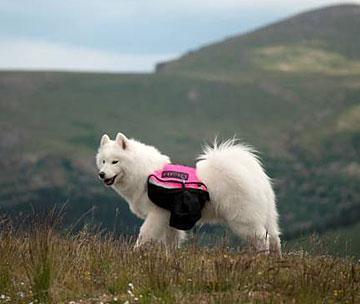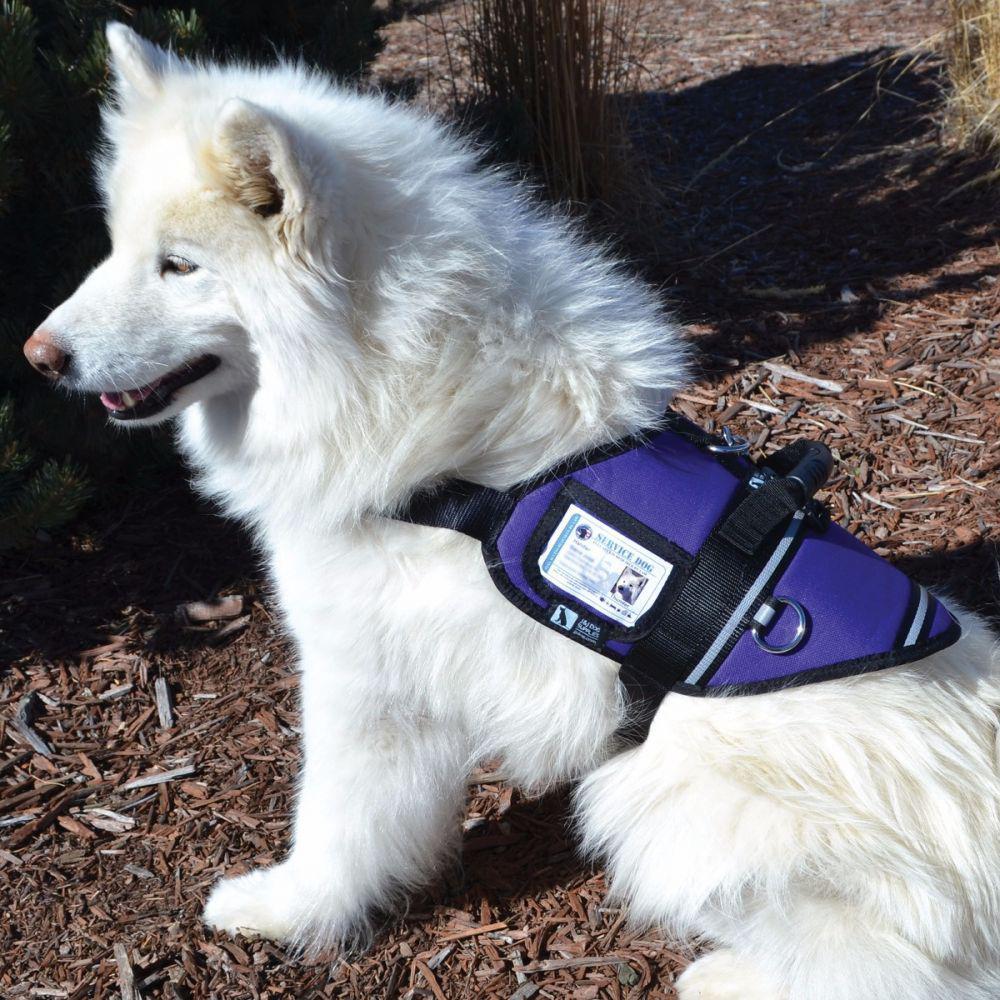The first image is the image on the left, the second image is the image on the right. Analyze the images presented: Is the assertion "there are multiple dogs in blue backpacks" valid? Answer yes or no. No. 